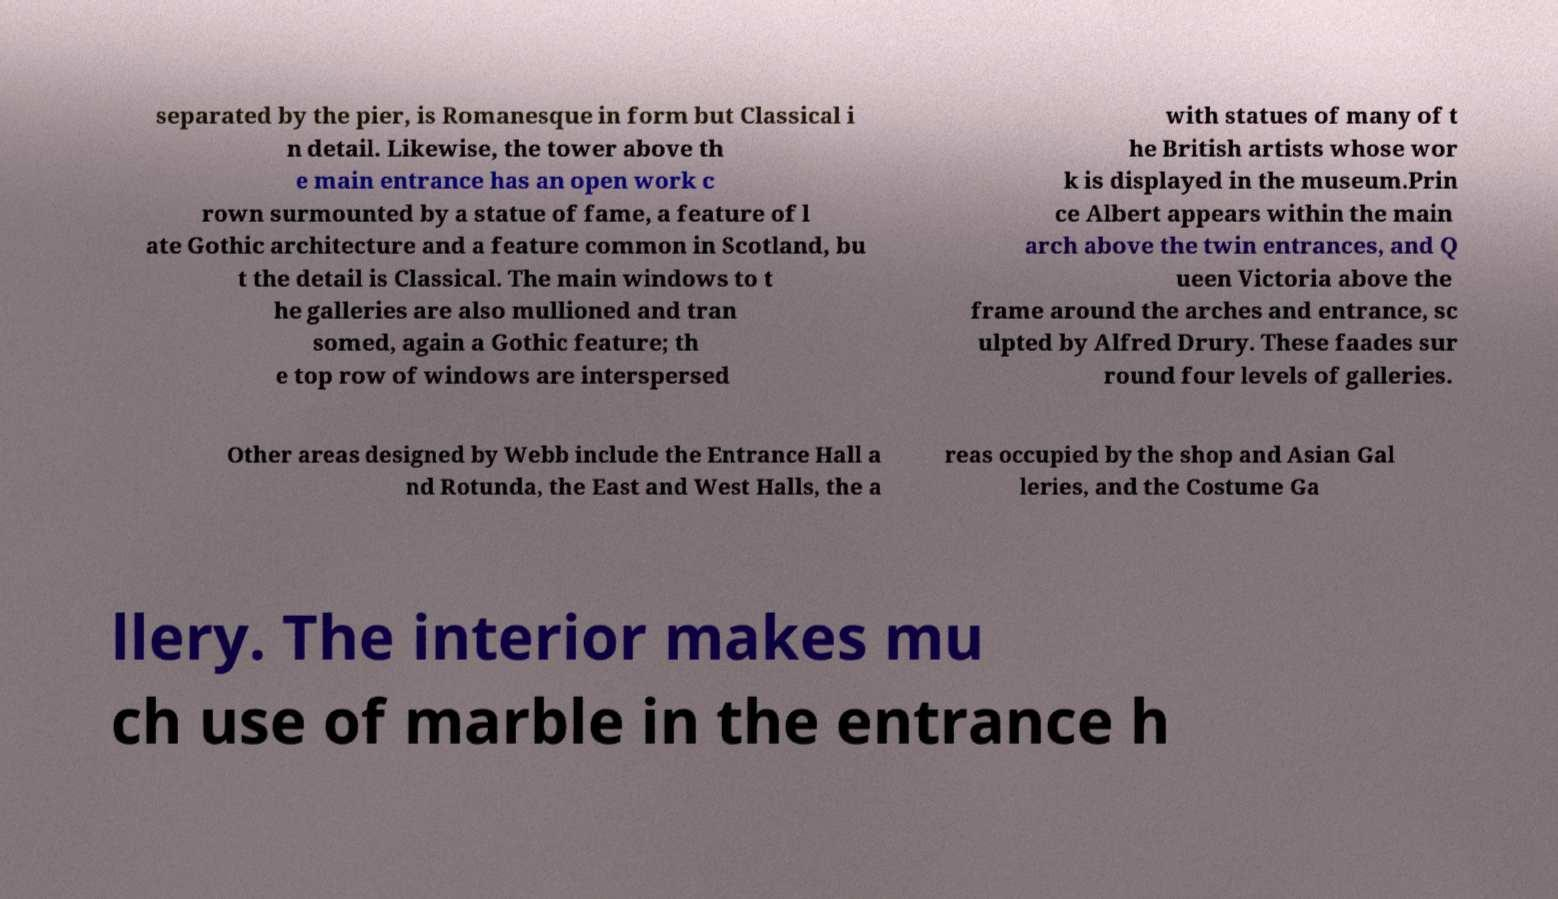Can you read and provide the text displayed in the image?This photo seems to have some interesting text. Can you extract and type it out for me? separated by the pier, is Romanesque in form but Classical i n detail. Likewise, the tower above th e main entrance has an open work c rown surmounted by a statue of fame, a feature of l ate Gothic architecture and a feature common in Scotland, bu t the detail is Classical. The main windows to t he galleries are also mullioned and tran somed, again a Gothic feature; th e top row of windows are interspersed with statues of many of t he British artists whose wor k is displayed in the museum.Prin ce Albert appears within the main arch above the twin entrances, and Q ueen Victoria above the frame around the arches and entrance, sc ulpted by Alfred Drury. These faades sur round four levels of galleries. Other areas designed by Webb include the Entrance Hall a nd Rotunda, the East and West Halls, the a reas occupied by the shop and Asian Gal leries, and the Costume Ga llery. The interior makes mu ch use of marble in the entrance h 